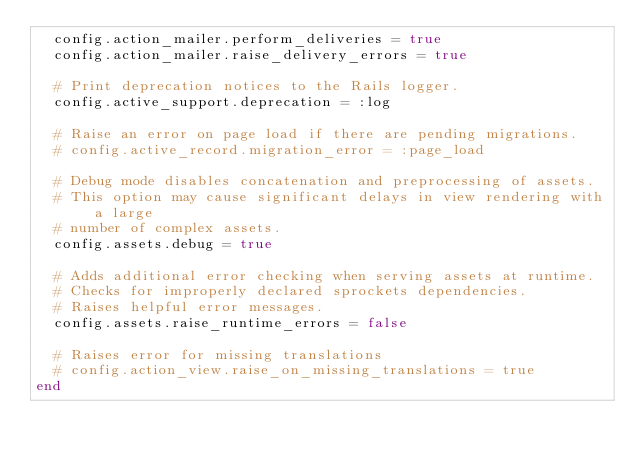Convert code to text. <code><loc_0><loc_0><loc_500><loc_500><_Ruby_>  config.action_mailer.perform_deliveries = true
  config.action_mailer.raise_delivery_errors = true
  
  # Print deprecation notices to the Rails logger.
  config.active_support.deprecation = :log

  # Raise an error on page load if there are pending migrations.
  # config.active_record.migration_error = :page_load

  # Debug mode disables concatenation and preprocessing of assets.
  # This option may cause significant delays in view rendering with a large
  # number of complex assets.
  config.assets.debug = true

  # Adds additional error checking when serving assets at runtime.
  # Checks for improperly declared sprockets dependencies.
  # Raises helpful error messages.
  config.assets.raise_runtime_errors = false

  # Raises error for missing translations
  # config.action_view.raise_on_missing_translations = true
end
</code> 